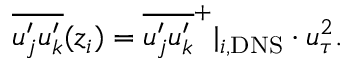<formula> <loc_0><loc_0><loc_500><loc_500>\overline { { u _ { j } ^ { \prime } u _ { k } ^ { \prime } } } ( z _ { i } ) = \overline { { u _ { j } ^ { \prime } u _ { k } ^ { \prime } } } ^ { + } | _ { i , D N S } \cdot u _ { \tau } ^ { 2 } .</formula> 